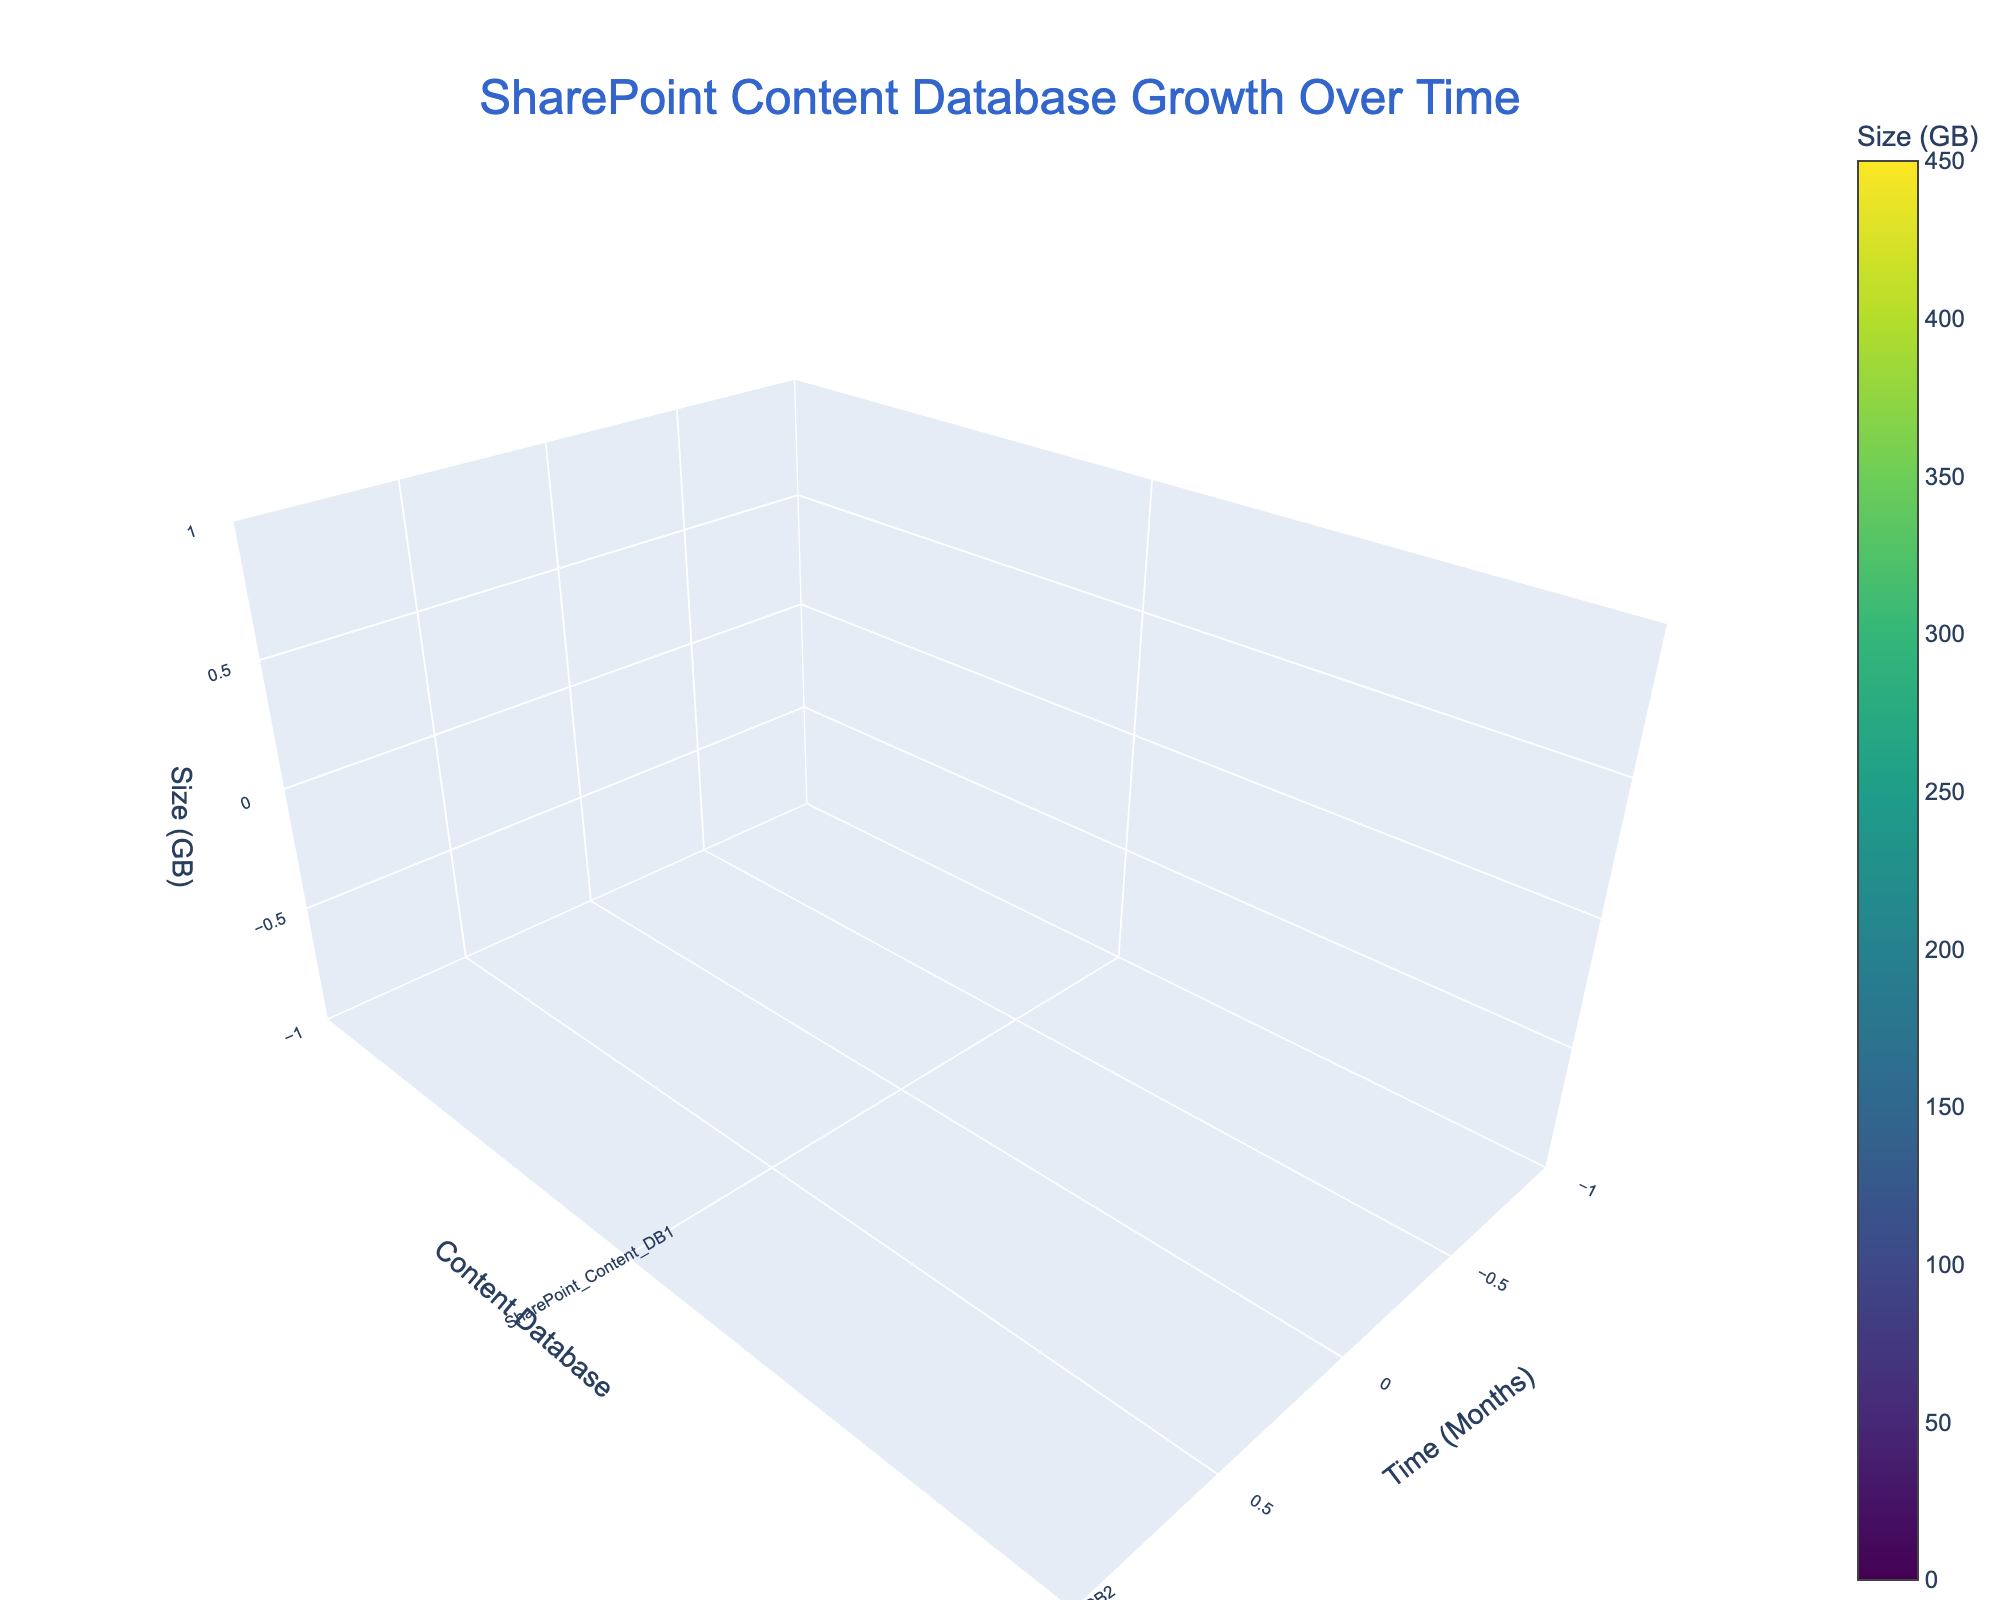What is the title of the figure? The title of the figure is usually displayed at the top of the figure. In this specific plot, it is centrally aligned and prominently sized to grab attention.
Answer: SharePoint Content Database Growth Over Time What are the axes labels in the figure? Axes labels are typically located next to the respective axes. For this plot, they are in a readable size and format. The x-axis is labeled "Time (Months)," the y-axis is labeled "Content Database," and the z-axis is labeled "Size (GB)."
Answer: Time (Months), Content Database, Size (GB) How many content databases are represented in the last time point (Month 12)? Count the unique content databases shown in the y-axis that have data points extending to the month 12 mark. These should correspond to the number of colored segments visible at the final x-axis tick.
Answer: 6 Which content database shows the most growth in size from Month 0 to Month 12? To identify the database with the most growth, you visually compare the differences in the length of the z-axis (size in GB) from Month 0 to Month 12 for each content database. Look for the largest increase.
Answer: SharePoint_Content_DB3 What is the size of SharePoint_Content_DB2 at Month 9? Locate the SharePoint_Content_DB2 data trace at Time (Months) = 9 on the x-axis and read its corresponding size value on the z-axis.
Answer: 220 GB What is the total storage size for all content databases at Month 3? Sum up the sizes of all the content databases at Time (Months) = 3. From the plot, visually inspect these values and add them together. This would be 150 + 110 + 180 + 50.
Answer: 490 GB Between SharePoint_Content_DB1 and SharePoint_Content_DB4, which database grew at a faster rate from Month 3 to Month 12? First, find the size difference for both databases from Month 3 to Month 12. SharePoint_Content_DB1 grows from 150 to 400 (400 - 150 = 250), and SharePoint_Content_DB4 grows from 50 to 250 (250 - 50 = 200). Compare these differences.
Answer: SharePoint_Content_DB1 What is the median size for all content databases at Month 6? Collect the sizes of all content databases at Month 6, sort them, and find the middle value. Sizes are 220, 160, 250, 100, 80. Sort these sizes as [80, 100, 160, 220, 250]. The median value is the one in the center.
Answer: 160 GB Which month shows the highest overall storage usage across all content databases? To find this, sum the storage sizes for each month and compare. The month with the highest sum is the one with the highest overall storage usage. Month 12 shows (400 + 300 + 450 + 250 + 220 + 100) = 1720 GB. Compare this with sums from other months.
Answer: Month 12 Is there any month where the total size of SharePoint_Content_DB4 and SharePoint_Content_DB5 is equal? Compare the sums of SharePoint_Content_DB4 and SharePoint_Content_DB5 for each month. For instance, at Month 6, their total is 100 (DB4) + 80 (DB5) = 180. Similarly, compare sums for other months to find any matches. No such equality exists in given data.
Answer: No 